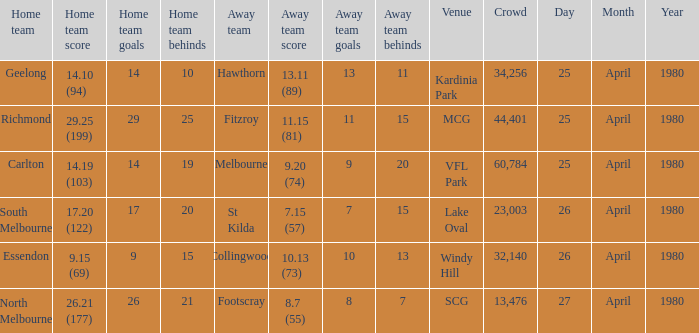What was the lowest crowd size at MCG? 44401.0. 